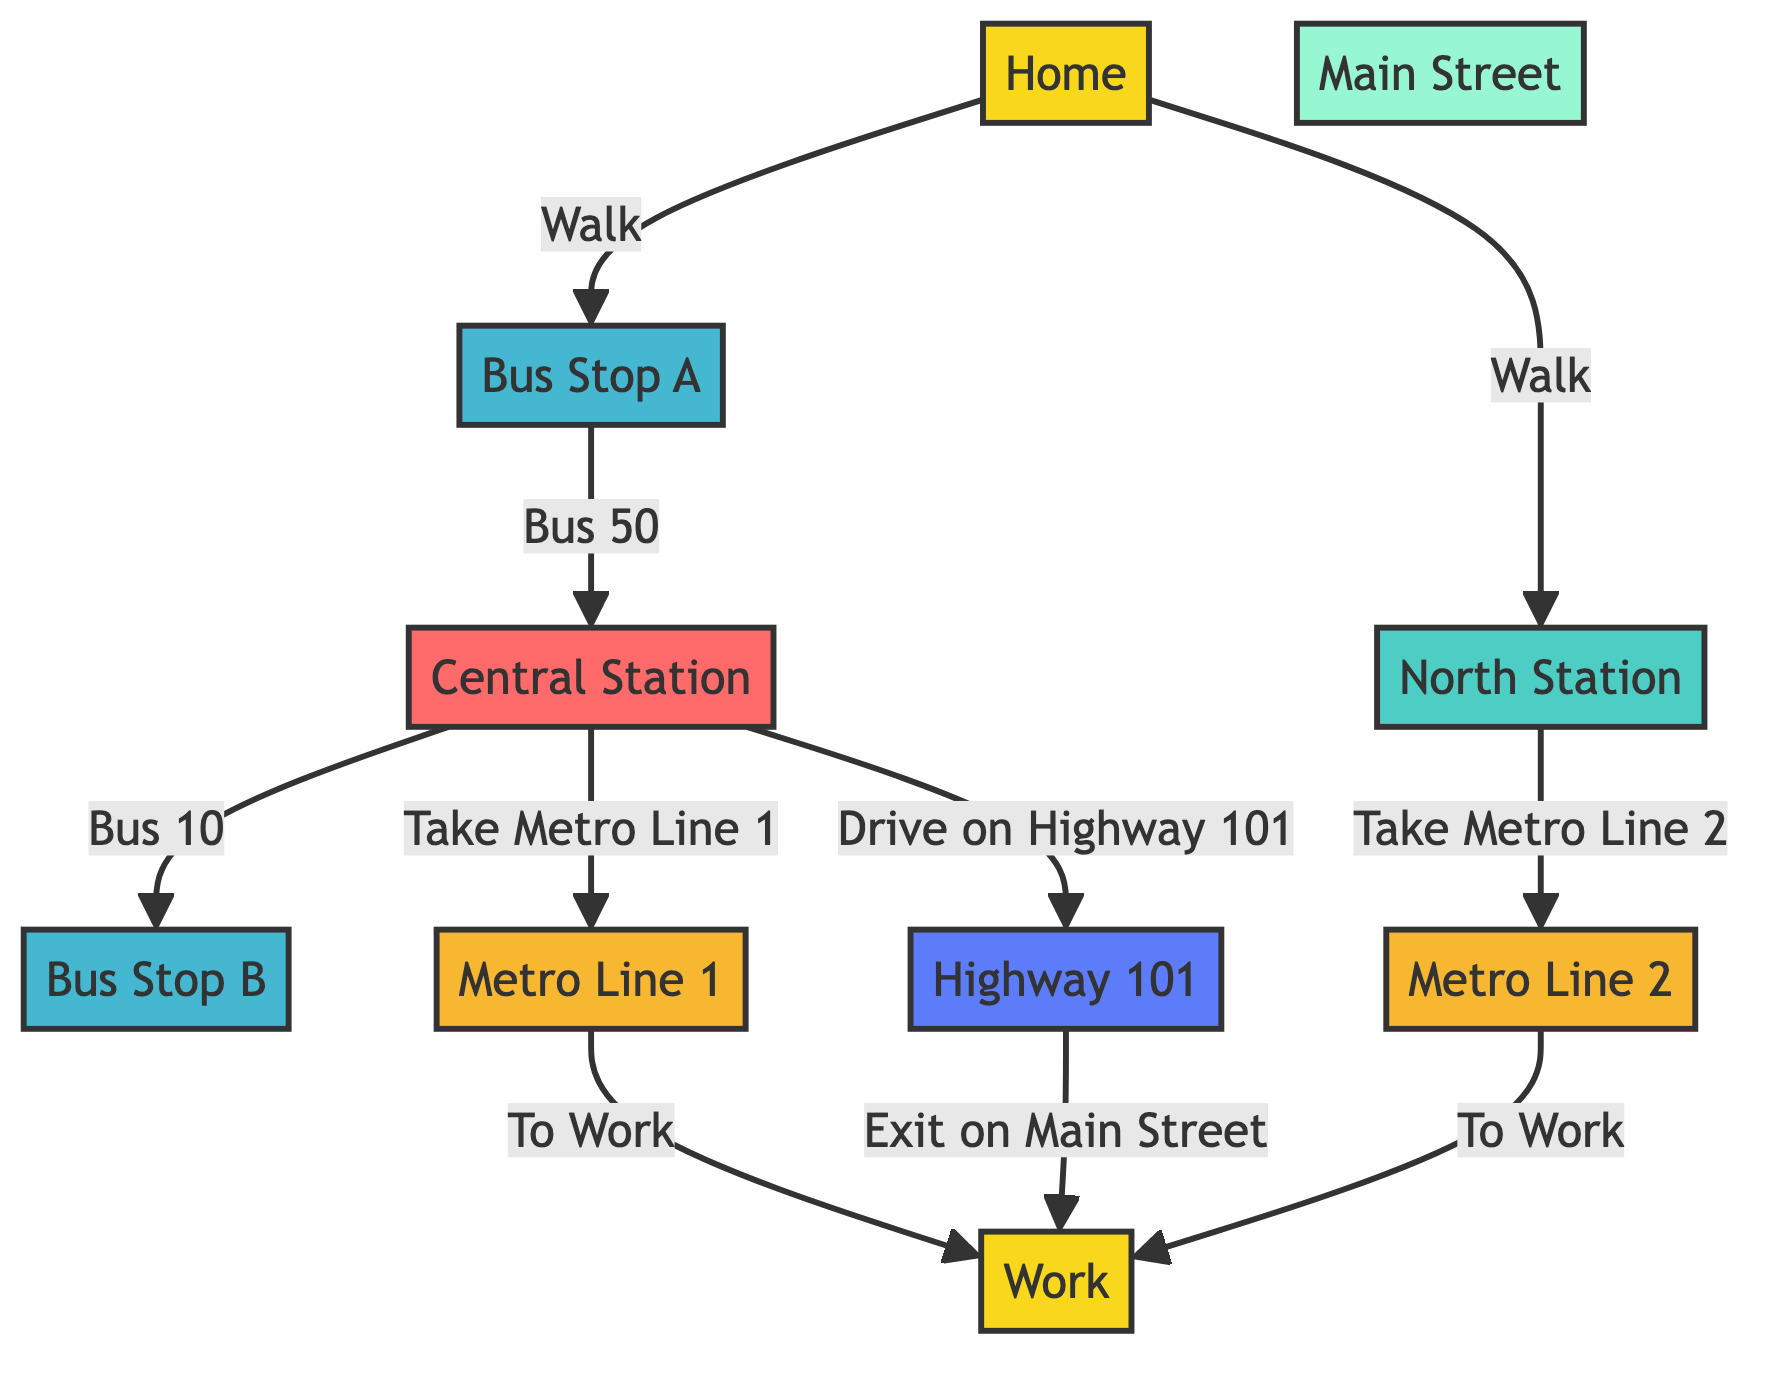What is the starting point of the commute? The starting point, as indicated by the diagram, is labeled as "Home" with node ID 1.
Answer: Home How many locations are identified in the diagram? The nodes labeled as locations are Home and Work, totaling two.
Answer: 2 Which bus stop connects to Central Station? Bus Stop A connects to Central Station through Bus 50, as shown by the edge in the diagram.
Answer: Bus Stop A What line do you take after arriving at Central Station to reach Work? After arriving at Central Station, you take Metro Line 1 to reach Work, as indicated in the connections.
Answer: Metro Line 1 How many highways lead to Work from Central Station? From Central Station, there is one highway (Highway 101) that leads to Work, shown by the edge leading from the highway to Work.
Answer: 1 If you walk to North Station, which metro line do you take to work? If you walk to North Station, you take Metro Line 2 to get to Work, as specified in the diagram's connections.
Answer: Metro Line 2 What is the transit mode from Bus Stop A to Central Station? The transit mode from Bus Stop A to Central Station is via Bus 50, which is directly labeled along the edge.
Answer: Bus 50 What is the last transfer point before reaching Work from Highway 101? The last transfer point before reaching Work from Highway 101 is Main Street, where you exit from the highway to reach Work.
Answer: Main Street What is the connection between Metro Line 1 and Work? Metro Line 1 connects directly to Work through a labeled edge that indicates the transit to Work.
Answer: To Work 